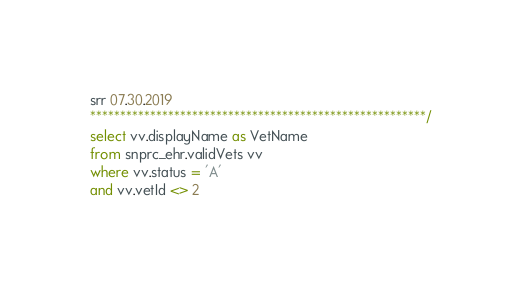<code> <loc_0><loc_0><loc_500><loc_500><_SQL_>
srr 07.30.2019
********************************************************/
select vv.displayName as VetName
from snprc_ehr.validVets vv
where vv.status = 'A'
and vv.vetId <> 2</code> 